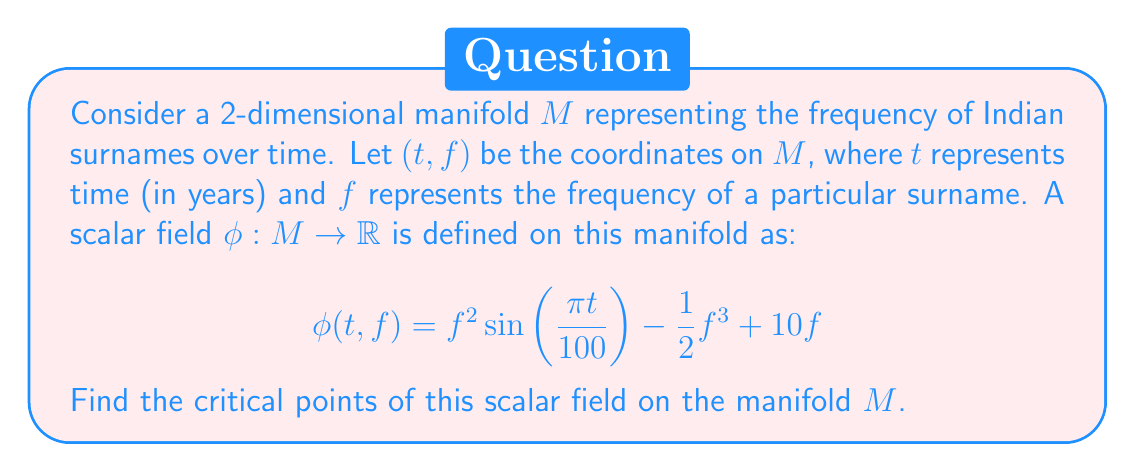Solve this math problem. To find the critical points of the scalar field $\phi$ on the manifold $M$, we need to follow these steps:

1) First, we need to calculate the partial derivatives of $\phi$ with respect to $t$ and $f$:

   $$\frac{\partial \phi}{\partial t} = f^2 \cos(\frac{\pi t}{100}) \cdot \frac{\pi}{100}$$
   $$\frac{\partial \phi}{\partial f} = 2f \sin(\frac{\pi t}{100}) - \frac{3}{2}f^2 + 10$$

2) The critical points are where both partial derivatives are simultaneously zero. So we need to solve the system of equations:

   $$f^2 \cos(\frac{\pi t}{100}) \cdot \frac{\pi}{100} = 0$$
   $$2f \sin(\frac{\pi t}{100}) - \frac{3}{2}f^2 + 10 = 0$$

3) From the first equation, we can deduce that either $f = 0$ or $\cos(\frac{\pi t}{100}) = 0$.

4) If $f = 0$, substituting this into the second equation gives:
   $$10 = 0$$
   which is false. So $f = 0$ is not a solution.

5) If $\cos(\frac{\pi t}{100}) = 0$, this occurs when $\frac{\pi t}{100} = \frac{\pi}{2} + \pi n$ for integer $n$. Solving this:
   $$t = 50 + 100n$$
   where $n$ is an integer.

6) When $\cos(\frac{\pi t}{100}) = 0$, we know that $\sin(\frac{\pi t}{100}) = \pm 1$. Substituting this into the second equation:
   $$\pm 2f - \frac{3}{2}f^2 + 10 = 0$$

7) Solving this quadratic equation:
   For $+1$: $f = 4$ or $f = \frac{10}{3}$
   For $-1$: $f = -2$ or $f = \frac{10}{3}$

Therefore, the critical points are of the form $(50 + 100n, 4)$, $(50 + 100n, \frac{10}{3})$, and $(150 + 100n, -2)$ for integer $n$.
Answer: The critical points of the scalar field $\phi$ on the manifold $M$ are:
$$(50 + 100n, 4), (50 + 100n, \frac{10}{3}), (150 + 100n, -2)$$
where $n$ is any integer. 